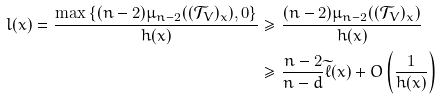Convert formula to latex. <formula><loc_0><loc_0><loc_500><loc_500>l ( x ) = \frac { \max \left \{ ( n - 2 ) \mu _ { n - 2 } ( ( \mathcal { T } _ { V } ) _ { x } ) , 0 \right \} } { h ( x ) } & \geq \frac { ( n - 2 ) \mu _ { n - 2 } ( ( \mathcal { T } _ { V } ) _ { x } ) } { h ( x ) } \\ & \geq \frac { n - 2 } { n - d } \widetilde { \ell } ( x ) + O \left ( \frac { 1 } { h ( x ) } \right )</formula> 